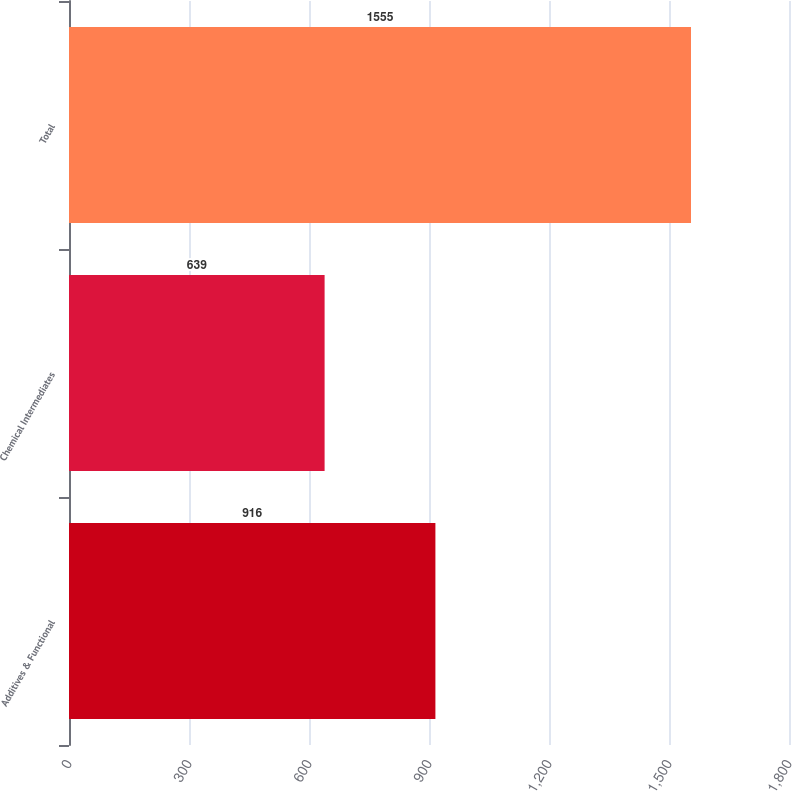Convert chart to OTSL. <chart><loc_0><loc_0><loc_500><loc_500><bar_chart><fcel>Additives & Functional<fcel>Chemical Intermediates<fcel>Total<nl><fcel>916<fcel>639<fcel>1555<nl></chart> 